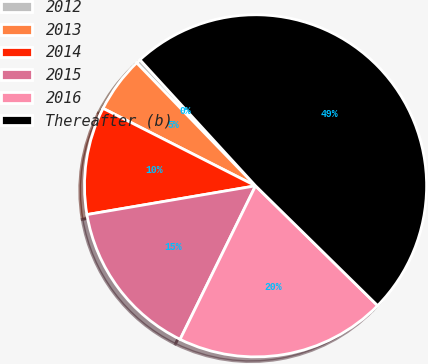Convert chart. <chart><loc_0><loc_0><loc_500><loc_500><pie_chart><fcel>2012<fcel>2013<fcel>2014<fcel>2015<fcel>2016<fcel>Thereafter (b)<nl><fcel>0.42%<fcel>5.29%<fcel>10.17%<fcel>15.04%<fcel>19.92%<fcel>49.16%<nl></chart> 